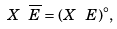Convert formula to latex. <formula><loc_0><loc_0><loc_500><loc_500>X \ \overline { E } = ( X \ E ) ^ { \circ } ,</formula> 